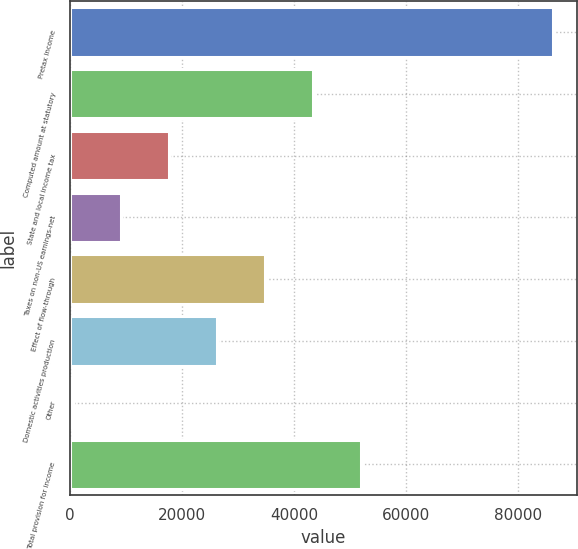Convert chart to OTSL. <chart><loc_0><loc_0><loc_500><loc_500><bar_chart><fcel>Pretax income<fcel>Computed amount at statutory<fcel>State and local income tax<fcel>Taxes on non-US earnings-net<fcel>Effect of flow-through<fcel>Domestic activities production<fcel>Other<fcel>Total provision for income<nl><fcel>86204<fcel>43403.5<fcel>17723.2<fcel>9163.1<fcel>34843.4<fcel>26283.3<fcel>603<fcel>51963.6<nl></chart> 